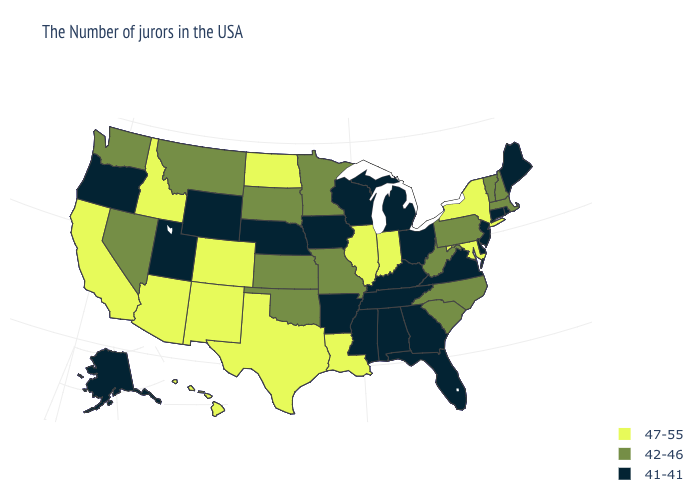What is the highest value in the USA?
Keep it brief. 47-55. How many symbols are there in the legend?
Quick response, please. 3. How many symbols are there in the legend?
Give a very brief answer. 3. Does New Jersey have the highest value in the Northeast?
Concise answer only. No. Name the states that have a value in the range 41-41?
Keep it brief. Maine, Rhode Island, Connecticut, New Jersey, Delaware, Virginia, Ohio, Florida, Georgia, Michigan, Kentucky, Alabama, Tennessee, Wisconsin, Mississippi, Arkansas, Iowa, Nebraska, Wyoming, Utah, Oregon, Alaska. Among the states that border Alabama , which have the highest value?
Quick response, please. Florida, Georgia, Tennessee, Mississippi. Among the states that border Alabama , which have the lowest value?
Give a very brief answer. Florida, Georgia, Tennessee, Mississippi. Which states have the lowest value in the West?
Be succinct. Wyoming, Utah, Oregon, Alaska. Does North Carolina have the highest value in the USA?
Be succinct. No. What is the lowest value in the MidWest?
Quick response, please. 41-41. Which states have the lowest value in the South?
Give a very brief answer. Delaware, Virginia, Florida, Georgia, Kentucky, Alabama, Tennessee, Mississippi, Arkansas. Name the states that have a value in the range 42-46?
Keep it brief. Massachusetts, New Hampshire, Vermont, Pennsylvania, North Carolina, South Carolina, West Virginia, Missouri, Minnesota, Kansas, Oklahoma, South Dakota, Montana, Nevada, Washington. Which states have the lowest value in the USA?
Short answer required. Maine, Rhode Island, Connecticut, New Jersey, Delaware, Virginia, Ohio, Florida, Georgia, Michigan, Kentucky, Alabama, Tennessee, Wisconsin, Mississippi, Arkansas, Iowa, Nebraska, Wyoming, Utah, Oregon, Alaska. What is the lowest value in the South?
Be succinct. 41-41. Name the states that have a value in the range 47-55?
Short answer required. New York, Maryland, Indiana, Illinois, Louisiana, Texas, North Dakota, Colorado, New Mexico, Arizona, Idaho, California, Hawaii. 